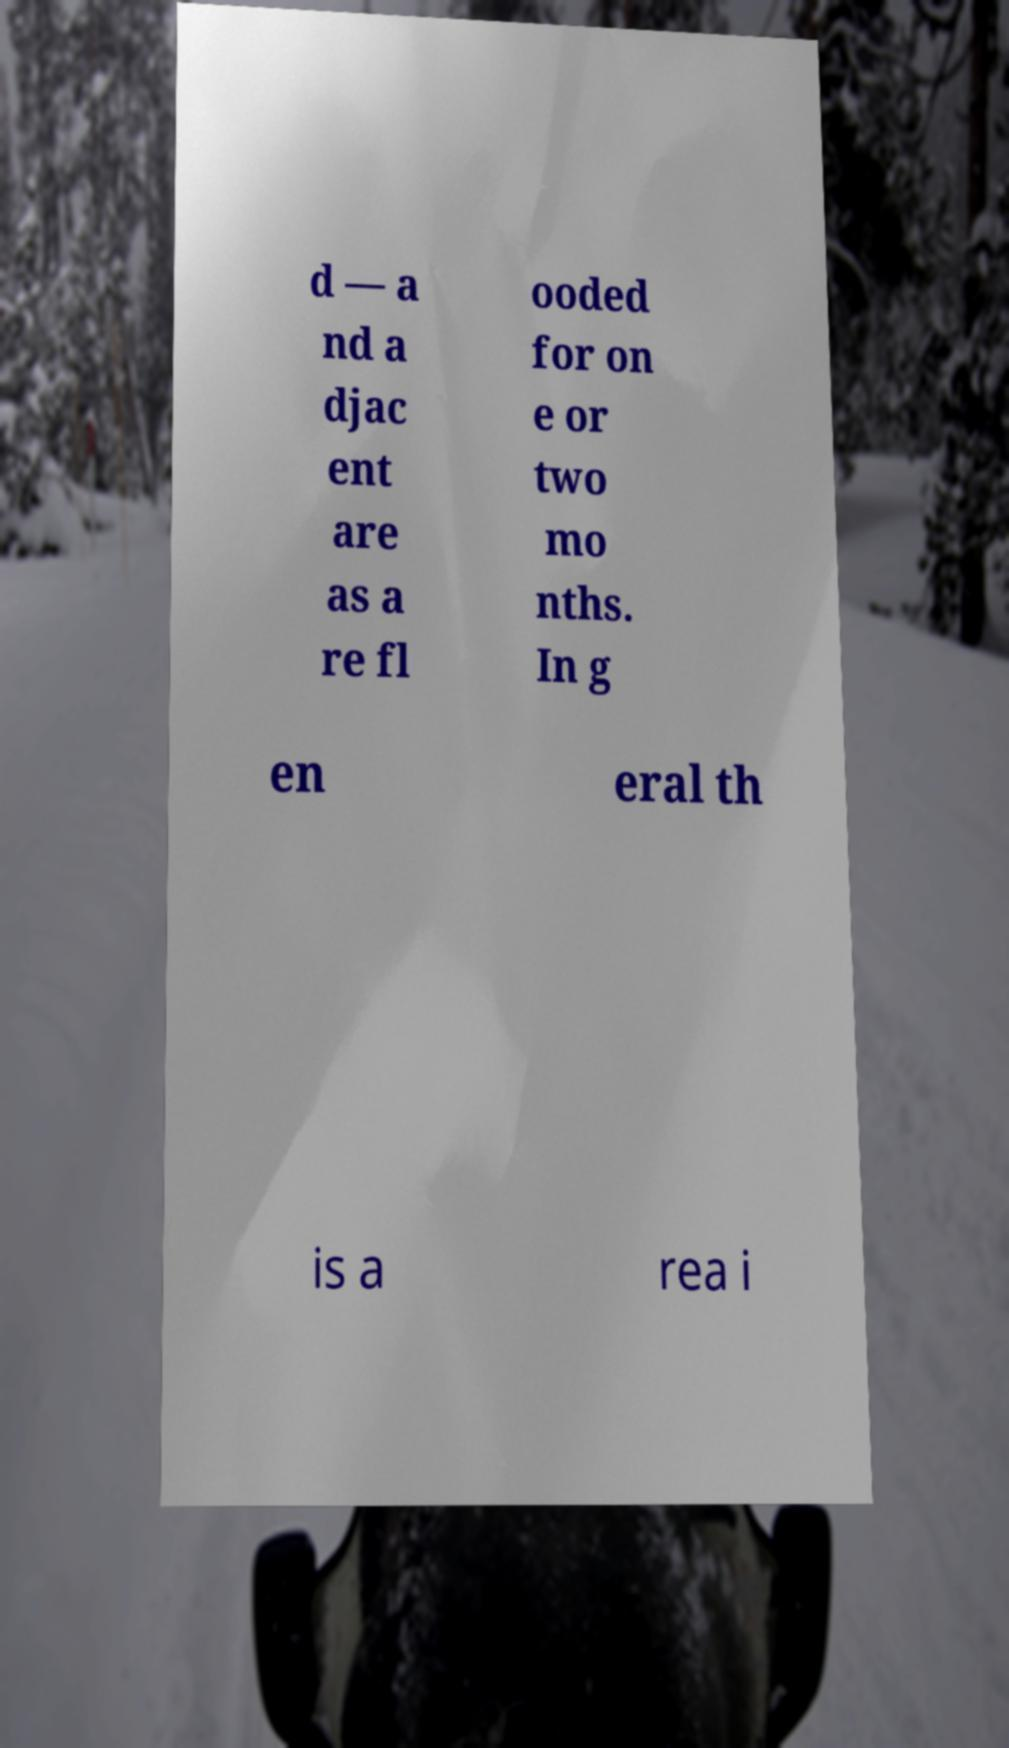For documentation purposes, I need the text within this image transcribed. Could you provide that? d — a nd a djac ent are as a re fl ooded for on e or two mo nths. In g en eral th is a rea i 